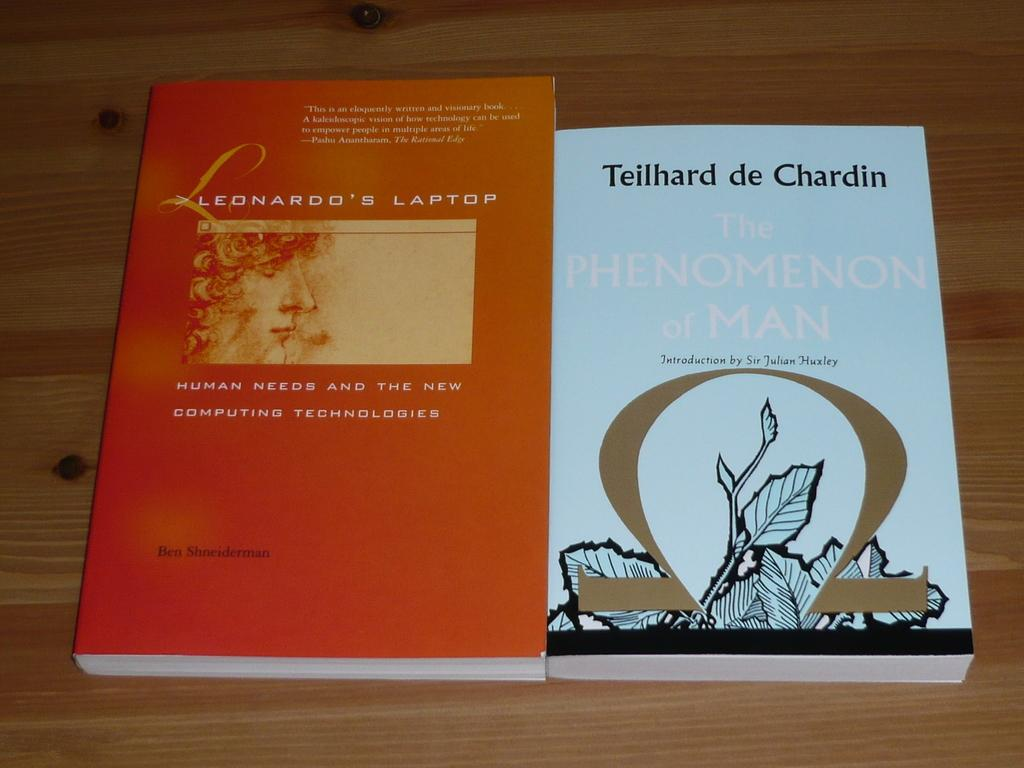<image>
Describe the image concisely. Two books sit side by side on a table, the left of which is titled Leonardo's Laptop. 